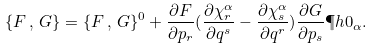Convert formula to latex. <formula><loc_0><loc_0><loc_500><loc_500>\{ F \, , \, G \} = \{ F \, , \, G \} ^ { 0 } + \frac { \partial F } { \partial p _ { r } } ( \frac { \partial \chi ^ { \alpha } _ { r } } { \partial q ^ { s } } - \frac { \partial \chi ^ { \alpha } _ { s } } { \partial q ^ { r } } ) \frac { \partial G } { \partial p _ { s } } \P h { 0 } _ { \alpha } .</formula> 